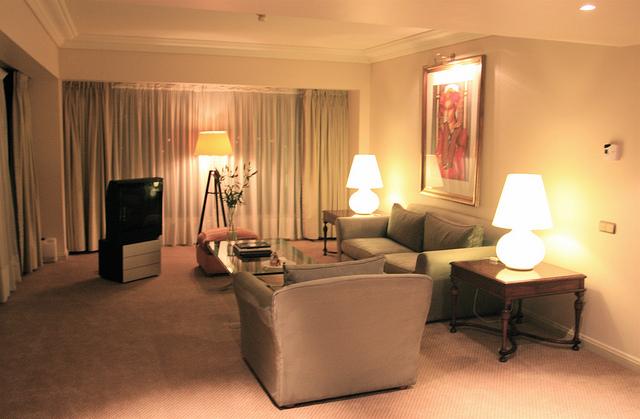What room is this?
Short answer required. Living room. Are there a lot of windows?
Be succinct. Yes. How many lamps are on?
Keep it brief. 3. 